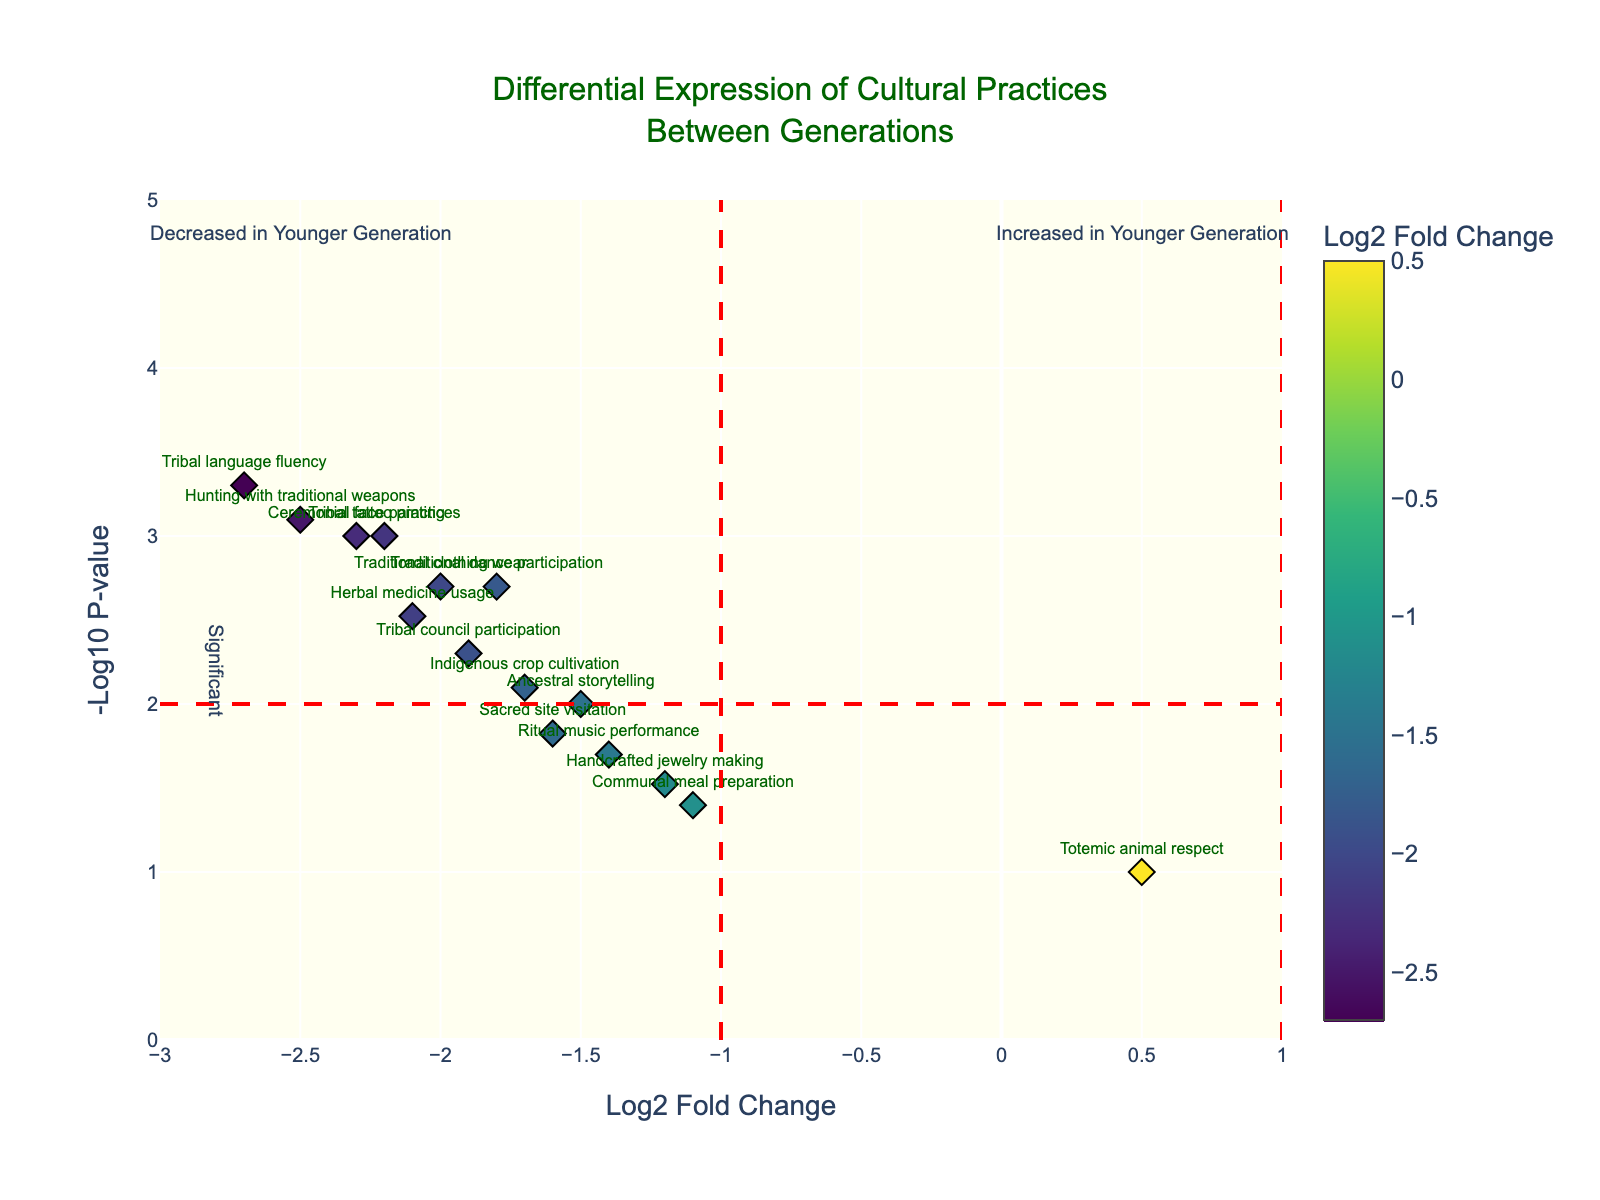What is the title of the figure? The title of the figure can be found at the top and usually provides a brief description of what the figure is about. In this case, it reads: "Differential Expression of Cultural Practices Between Generations."
Answer: Differential Expression of Cultural Practices Between Generations Which cultural practice shows the largest negative log2 fold change? The largest negative log2 fold change indicates the most significant decrease in younger generations compared to older generations. By looking at the x-axis, the cultural practice with the largest negative value is "Tribal language fluency" with a log2 fold change of -2.7.
Answer: Tribal language fluency How many cultural practices have a p-value less than 0.01? To find this, we look at the y-axis values to identify points above -log10(p-value) of 2, which corresponds to a p-value of 0.01. Counting these points gives us the practices with significant p-values.
Answer: 11 What is the log2 fold change and -log10 p-value of "Ceremonial face painting"? The log2 fold change and -log10 p-value for "Ceremonial face painting" can be found by locating its mark and reading the values: The log2 fold change is -2.3 and the -log10 p-value is approximately 3.
Answer: -2.3, 3 Which cultural practice shows an increase in the younger generation? An increase in the younger generation is indicated by a positive log2 fold change. "Totemic animal respect" is the only cultural practice with a positive log2 fold change.
Answer: Totemic animal respect How many cultural practices are significantly different between the generations? Significant differences are typically determined by both a high -log10 p-value (above 2) and notable log2 fold changes (either much greater or less than 0). By counting the markers above these thresholds, we determine the significant ones.
Answer: 11 Which cultural practice has the highest p-value among those that show a decrease in the younger generation? Recall that a higher p-value corresponds to a lower y-value on the plot. Among the practices with a negative log2 fold change, "Communal meal preparation" has the highest p-value as it appears lowest on the y-axis.
Answer: Communal meal preparation What does the position of "Ritual music performance" imply about its adoption across generations? "Ritual music performance" has a log2 fold change of -1.4 and a -log10 p-value around 1.7. The negative log2 fold change indicates it is less adopted by the younger generation, and a lower -log10 p-value suggests this difference is not as statistically significant as others.
Answer: Less adopted by younger generation, less significant What is the range of log2 fold change shown on the x-axis? The x-axis range denotes the extent of fold changes measured in the survey; in this plot, it spans values from -3 to 1.
Answer: -3 to 1 What cultural practices fall below the significance threshold line at -log10(p) = 2, and what does this mean? Point practices under the line have p-values > 0.01, indicating less statistically significant differences between generations. These include "Handcrafted jewelry making," "Ritual music performance," "Communal meal preparation," and "Totemic animal respect."
Answer: Less statistically significant differences 